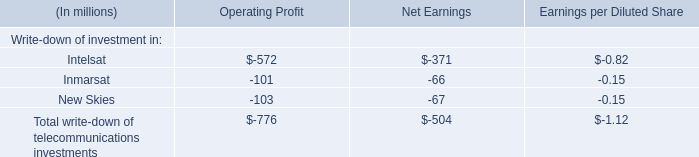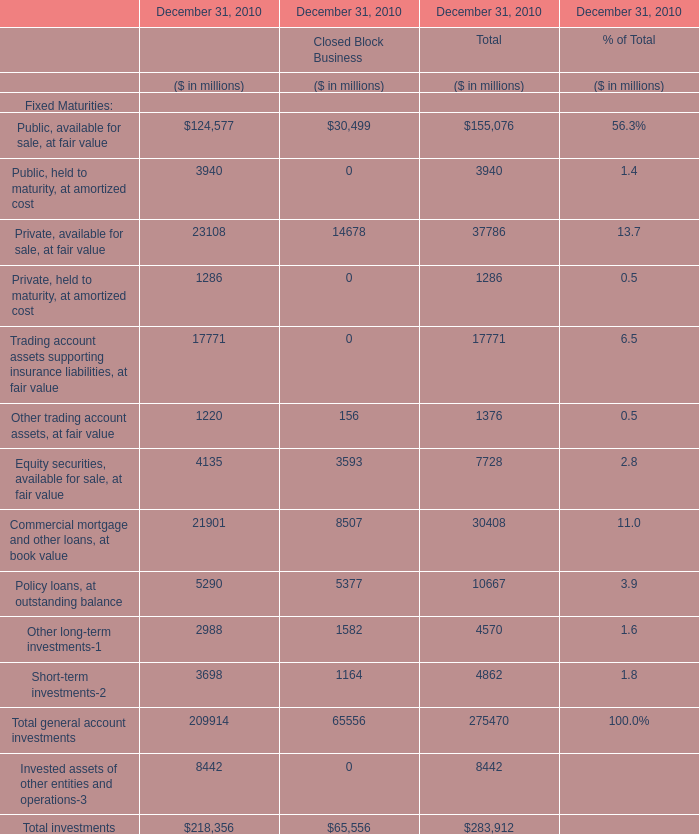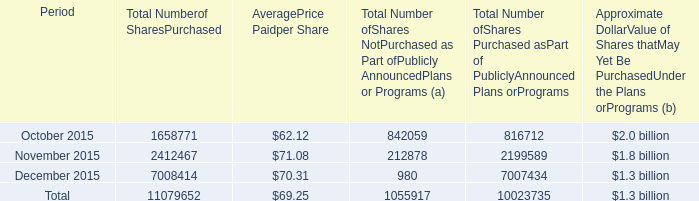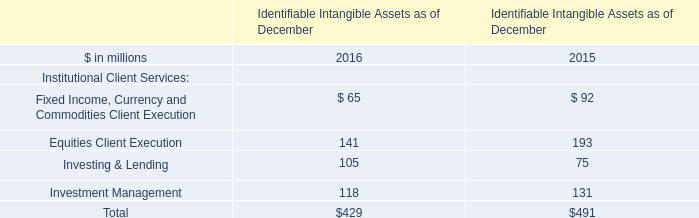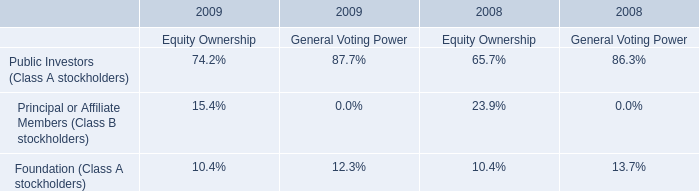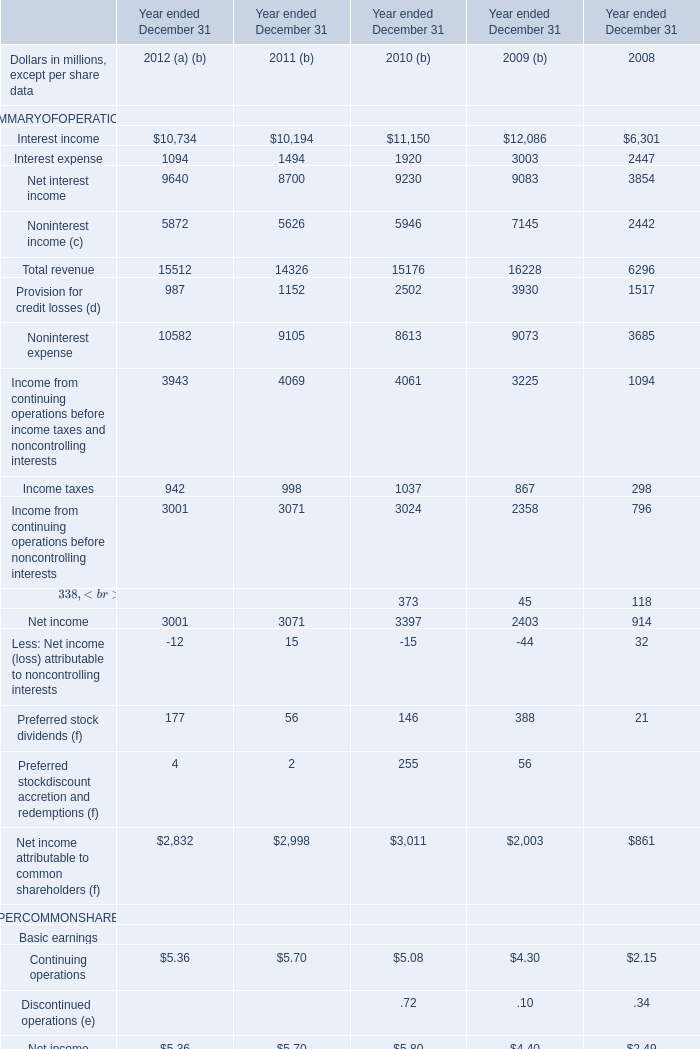as of december 31 , 2015 , what was the percent of the $ 2.5 billion program remaining available for purchase 
Computations: (1.3 / 2.5)
Answer: 0.52. 